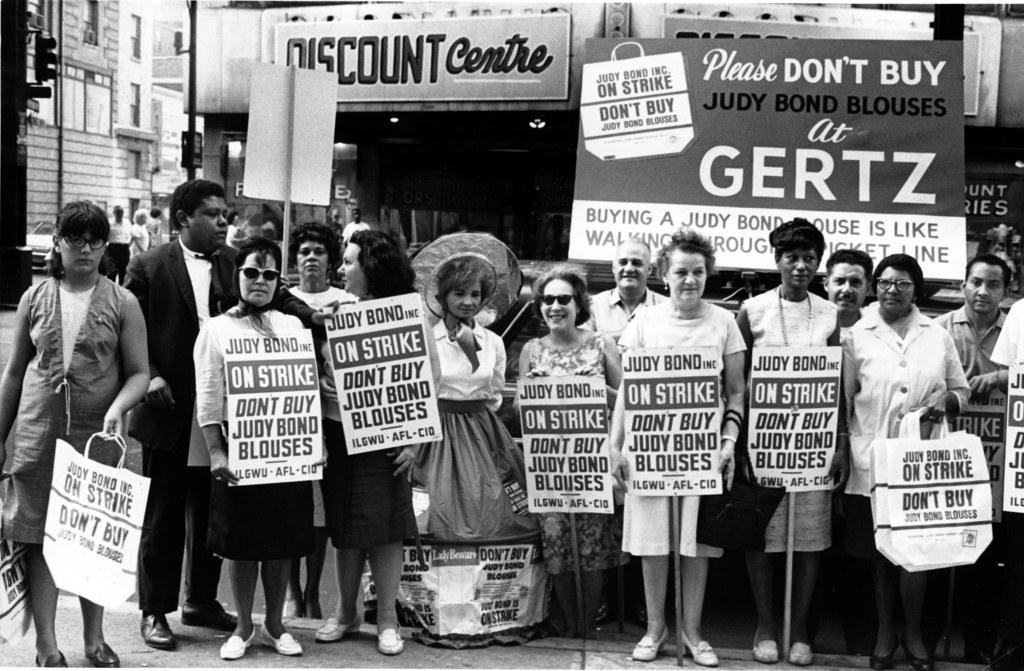Could you give a brief overview of what you see in this image? This picture is in black and white. In front of the picture, we see people are standing on the road. Most of them are holding a whiteboard with some text written on it. The woman on the left side is holding a white bag with some text written on it. I think they are protesting against something. Behind them, we see hoarding boards with some text written on it. We see people are standing. There are buildings and a traffic signal in the background. This picture is clicked outside the city. 